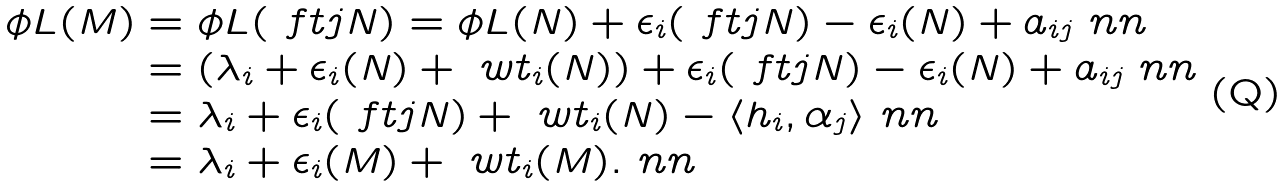Convert formula to latex. <formula><loc_0><loc_0><loc_500><loc_500>\phi L ( M ) & = \phi L ( \ f t { j } N ) = \phi L ( N ) + \epsilon _ { i } ( \ f t { j } N ) - \epsilon _ { i } ( N ) + a _ { i j } \ n n \\ & = ( \lambda _ { i } + \epsilon _ { i } ( N ) + \ w t _ { i } ( N ) ) + \epsilon _ { i } ( \ f t { j } N ) - \epsilon _ { i } ( N ) + a _ { i j } \ n n \\ & = \lambda _ { i } + \epsilon _ { i } ( \ f t { j } N ) + \ w t _ { i } ( N ) - \langle h _ { i } , \alpha _ { j } \rangle \ n n \\ & = \lambda _ { i } + \epsilon _ { i } ( M ) + \ w t _ { i } ( M ) . \ n n</formula> 